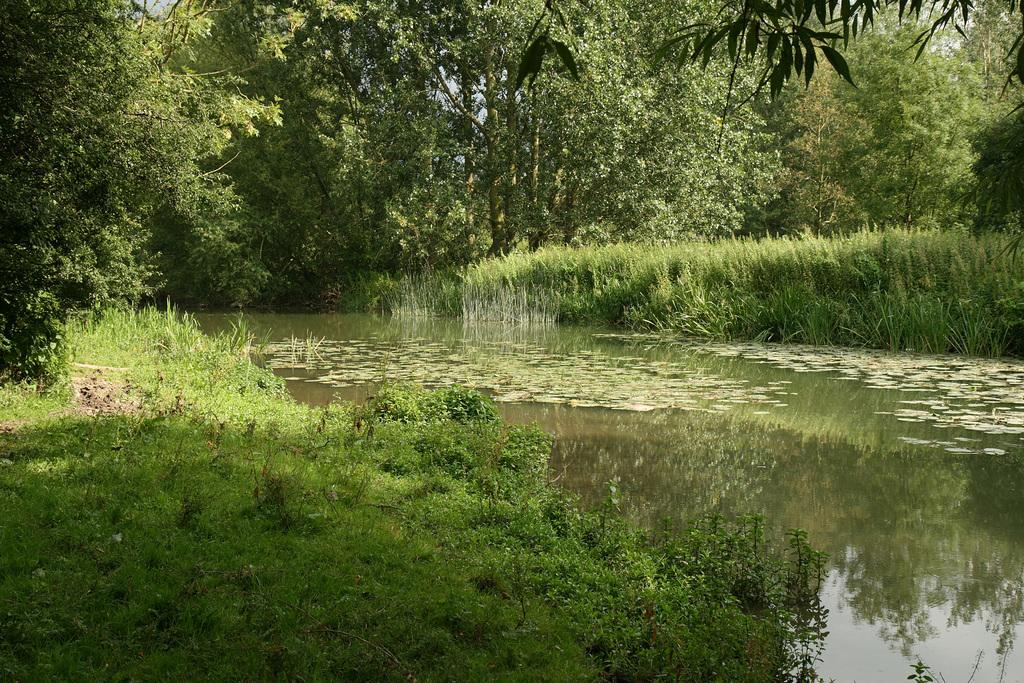What type of vegetation is present at the bottom of the picture? There is grass and herbs at the bottom of the picture. Is there any water visible at the bottom of the picture? Yes, there is water at the bottom of the picture, possibly in a pond. What can be seen in the background of the picture? There are trees in the background of the picture. What type of pen is floating on the water in the image? There is no pen present in the image; it only features grass, herbs, water, and trees. 